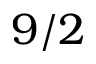Convert formula to latex. <formula><loc_0><loc_0><loc_500><loc_500>9 / 2</formula> 